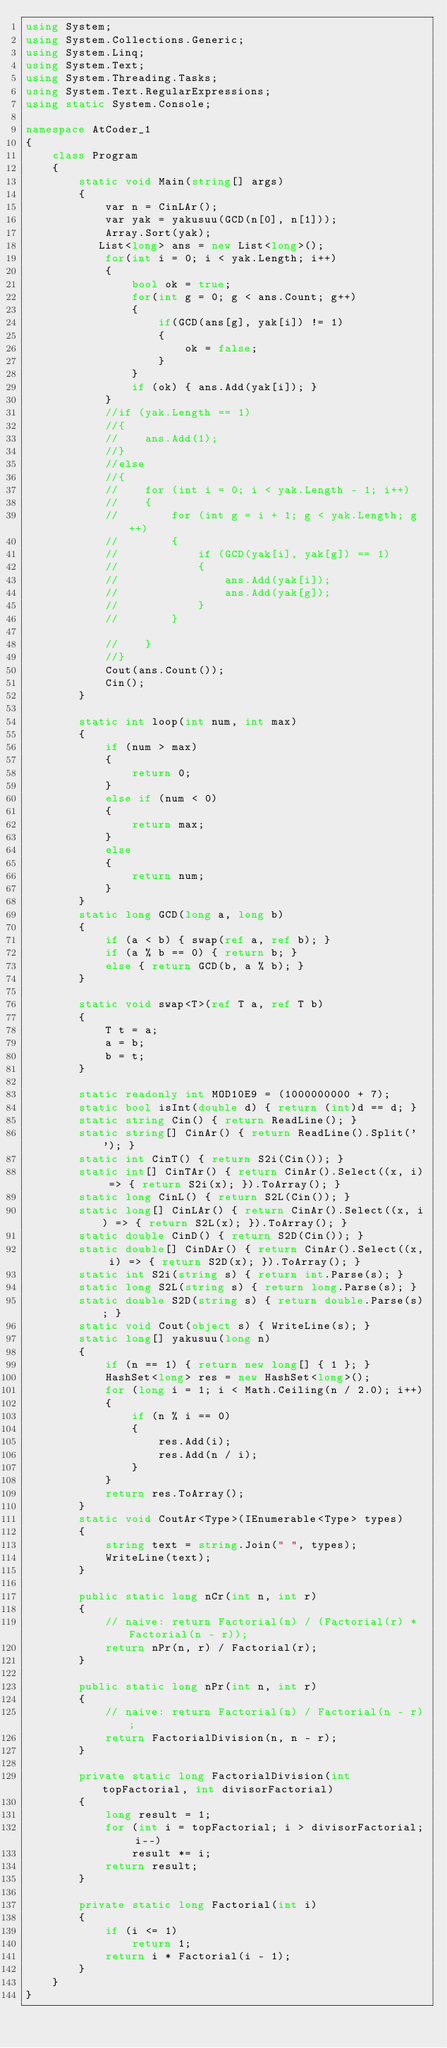<code> <loc_0><loc_0><loc_500><loc_500><_C#_>using System;
using System.Collections.Generic;
using System.Linq;
using System.Text;
using System.Threading.Tasks;
using System.Text.RegularExpressions;
using static System.Console;

namespace AtCoder_1
{
    class Program
    {
        static void Main(string[] args)
        {
            var n = CinLAr();
            var yak = yakusuu(GCD(n[0], n[1]));
            Array.Sort(yak);
           List<long> ans = new List<long>();
            for(int i = 0; i < yak.Length; i++)
            {
                bool ok = true;
                for(int g = 0; g < ans.Count; g++)
                {
                    if(GCD(ans[g], yak[i]) != 1)
                    {
                        ok = false;
                    }
                }
                if (ok) { ans.Add(yak[i]); }
            }
            //if (yak.Length == 1)
            //{
            //    ans.Add(1);
            //}
            //else
            //{
            //    for (int i = 0; i < yak.Length - 1; i++)
            //    {
            //        for (int g = i + 1; g < yak.Length; g++)
            //        {
            //            if (GCD(yak[i], yak[g]) == 1)
            //            {
            //                ans.Add(yak[i]);
            //                ans.Add(yak[g]);
            //            }
            //        }

            //    }
            //}
            Cout(ans.Count());
            Cin();
        }

        static int loop(int num, int max)
        {
            if (num > max)
            {
                return 0;
            }
            else if (num < 0)
            {
                return max;
            }
            else
            {
                return num;
            }
        }
        static long GCD(long a, long b)
        {
            if (a < b) { swap(ref a, ref b); }
            if (a % b == 0) { return b; }
            else { return GCD(b, a % b); }
        }

        static void swap<T>(ref T a, ref T b)
        {
            T t = a;
            a = b;
            b = t;
        }

        static readonly int MOD10E9 = (1000000000 + 7);
        static bool isInt(double d) { return (int)d == d; }
        static string Cin() { return ReadLine(); }
        static string[] CinAr() { return ReadLine().Split(' '); }
        static int CinT() { return S2i(Cin()); }
        static int[] CinTAr() { return CinAr().Select((x, i) => { return S2i(x); }).ToArray(); }
        static long CinL() { return S2L(Cin()); }
        static long[] CinLAr() { return CinAr().Select((x, i) => { return S2L(x); }).ToArray(); }
        static double CinD() { return S2D(Cin()); }
        static double[] CinDAr() { return CinAr().Select((x, i) => { return S2D(x); }).ToArray(); }
        static int S2i(string s) { return int.Parse(s); }
        static long S2L(string s) { return long.Parse(s); }
        static double S2D(string s) { return double.Parse(s); }
        static void Cout(object s) { WriteLine(s); }
        static long[] yakusuu(long n)
        {
            if (n == 1) { return new long[] { 1 }; }
            HashSet<long> res = new HashSet<long>();
            for (long i = 1; i < Math.Ceiling(n / 2.0); i++)
            {
                if (n % i == 0)
                {
                    res.Add(i);
                    res.Add(n / i);
                }
            }
            return res.ToArray();
        }
        static void CoutAr<Type>(IEnumerable<Type> types)
        {
            string text = string.Join(" ", types);
            WriteLine(text);
        }

        public static long nCr(int n, int r)
        {
            // naive: return Factorial(n) / (Factorial(r) * Factorial(n - r));
            return nPr(n, r) / Factorial(r);
        }

        public static long nPr(int n, int r)
        {
            // naive: return Factorial(n) / Factorial(n - r);
            return FactorialDivision(n, n - r);
        }

        private static long FactorialDivision(int topFactorial, int divisorFactorial)
        {
            long result = 1;
            for (int i = topFactorial; i > divisorFactorial; i--)
                result *= i;
            return result;
        }

        private static long Factorial(int i)
        {
            if (i <= 1)
                return 1;
            return i * Factorial(i - 1);
        }
    }
}
</code> 